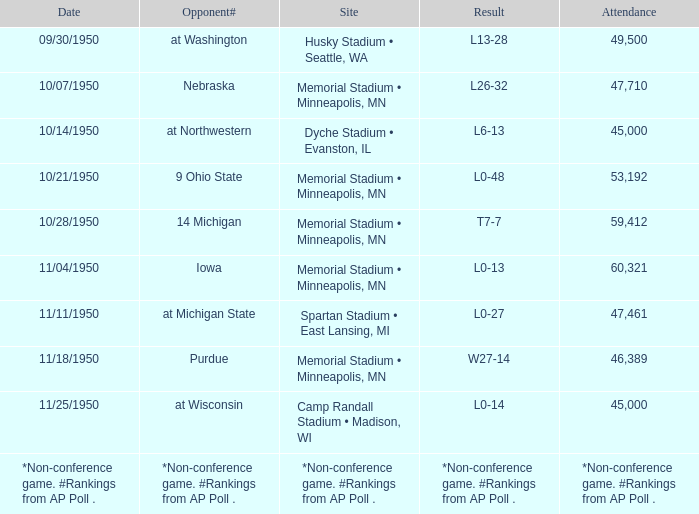What is the Date when the result is *non-conference game. #rankings from ap poll .? *Non-conference game. #Rankings from AP Poll . 